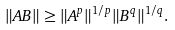<formula> <loc_0><loc_0><loc_500><loc_500>\| A B \| \geq \| A ^ { p } \| ^ { 1 / p } \| B ^ { q } \| ^ { 1 / q } .</formula> 